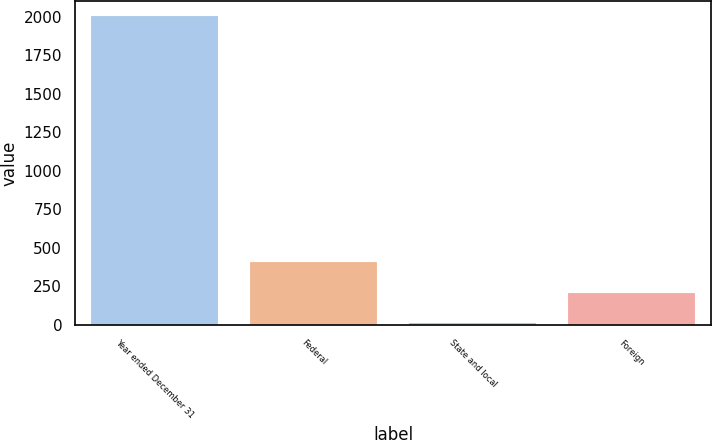Convert chart. <chart><loc_0><loc_0><loc_500><loc_500><bar_chart><fcel>Year ended December 31<fcel>Federal<fcel>State and local<fcel>Foreign<nl><fcel>2004<fcel>409.84<fcel>11.3<fcel>210.57<nl></chart> 